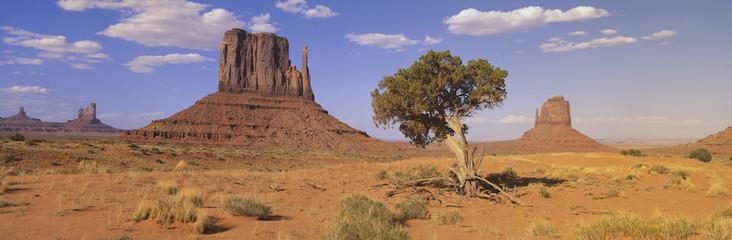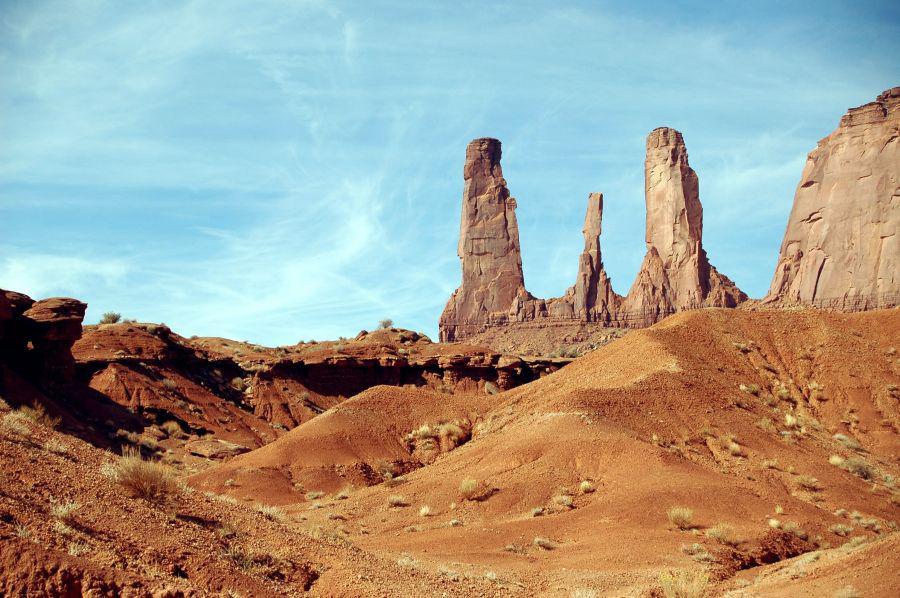The first image is the image on the left, the second image is the image on the right. Analyze the images presented: Is the assertion "In the left image, there is an upright object in the foreground with rock formations behind." valid? Answer yes or no. Yes. The first image is the image on the left, the second image is the image on the right. For the images shown, is this caption "The left and right images show the same view of three rock formations, but under different sky conditions." true? Answer yes or no. No. 